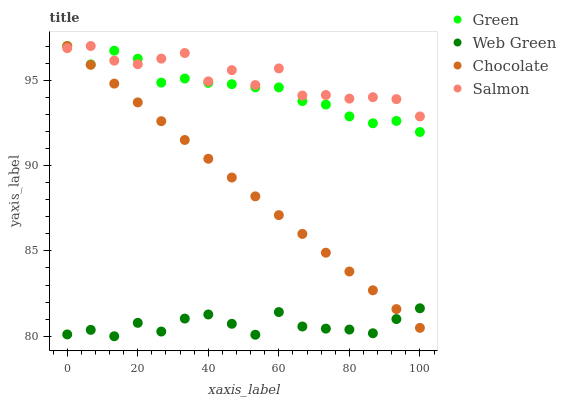Does Web Green have the minimum area under the curve?
Answer yes or no. Yes. Does Salmon have the maximum area under the curve?
Answer yes or no. Yes. Does Green have the minimum area under the curve?
Answer yes or no. No. Does Green have the maximum area under the curve?
Answer yes or no. No. Is Chocolate the smoothest?
Answer yes or no. Yes. Is Salmon the roughest?
Answer yes or no. Yes. Is Green the smoothest?
Answer yes or no. No. Is Green the roughest?
Answer yes or no. No. Does Web Green have the lowest value?
Answer yes or no. Yes. Does Green have the lowest value?
Answer yes or no. No. Does Chocolate have the highest value?
Answer yes or no. Yes. Does Web Green have the highest value?
Answer yes or no. No. Is Web Green less than Green?
Answer yes or no. Yes. Is Green greater than Web Green?
Answer yes or no. Yes. Does Chocolate intersect Salmon?
Answer yes or no. Yes. Is Chocolate less than Salmon?
Answer yes or no. No. Is Chocolate greater than Salmon?
Answer yes or no. No. Does Web Green intersect Green?
Answer yes or no. No. 